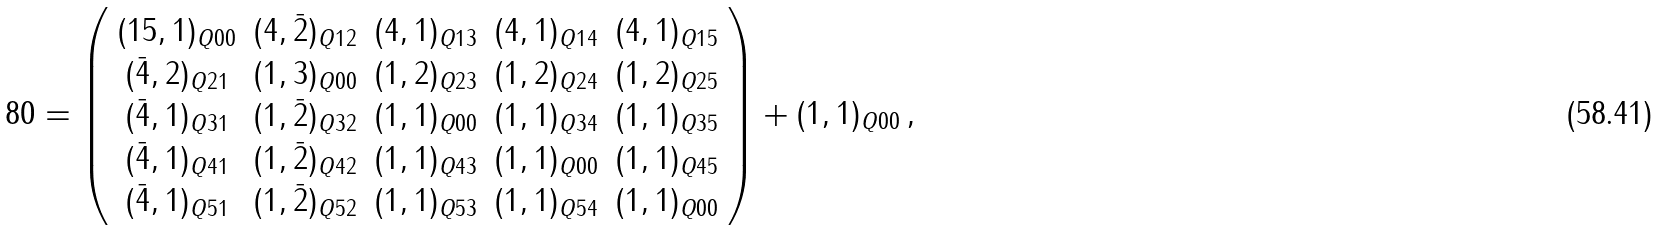<formula> <loc_0><loc_0><loc_500><loc_500>8 0 = \left ( \begin{array} { c c c c c } ( 1 5 , 1 ) _ { Q 0 0 } & ( 4 , \bar { 2 } ) _ { Q 1 2 } & ( 4 , 1 ) _ { Q 1 3 } & ( 4 , 1 ) _ { Q 1 4 } & ( 4 , 1 ) _ { Q 1 5 } \\ ( \bar { 4 } , 2 ) _ { Q 2 1 } & ( 1 , 3 ) _ { Q 0 0 } & ( 1 , 2 ) _ { Q 2 3 } & ( 1 , 2 ) _ { Q 2 4 } & ( 1 , 2 ) _ { Q 2 5 } \\ ( \bar { 4 } , 1 ) _ { Q 3 1 } & ( 1 , \bar { 2 } ) _ { Q 3 2 } & ( 1 , 1 ) _ { Q 0 0 } & ( 1 , 1 ) _ { Q 3 4 } & ( 1 , 1 ) _ { Q 3 5 } \\ ( \bar { 4 } , 1 ) _ { Q 4 1 } & ( 1 , \bar { 2 } ) _ { Q 4 2 } & ( 1 , 1 ) _ { Q 4 3 } & ( 1 , 1 ) _ { Q 0 0 } & ( 1 , 1 ) _ { Q 4 5 } \\ ( \bar { 4 } , 1 ) _ { Q 5 1 } & ( 1 , \bar { 2 } ) _ { Q 5 2 } & ( 1 , 1 ) _ { Q 5 3 } & ( 1 , 1 ) _ { Q 5 4 } & ( 1 , 1 ) _ { Q 0 0 } \end{array} \right ) + ( 1 , 1 ) _ { Q 0 0 } \, ,</formula> 